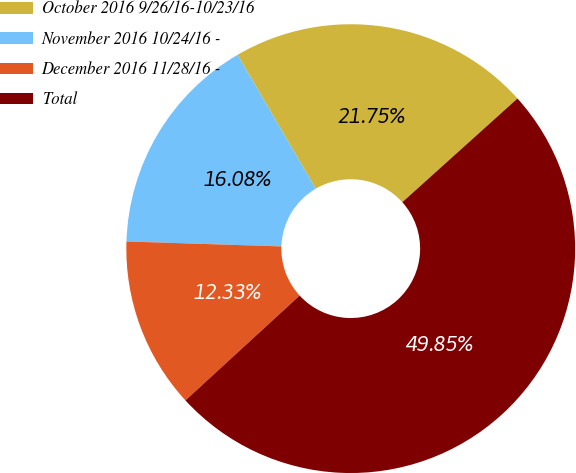<chart> <loc_0><loc_0><loc_500><loc_500><pie_chart><fcel>October 2016 9/26/16-10/23/16<fcel>November 2016 10/24/16 -<fcel>December 2016 11/28/16 -<fcel>Total<nl><fcel>21.75%<fcel>16.08%<fcel>12.33%<fcel>49.85%<nl></chart> 